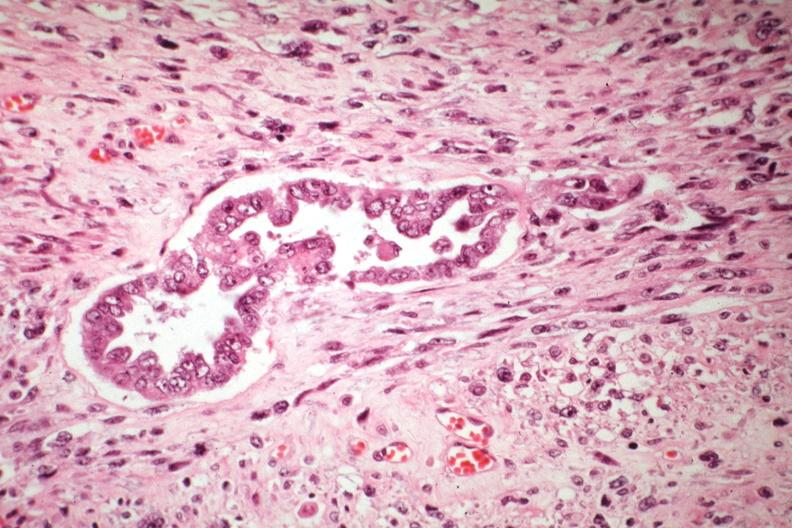does this image show malignant gland and stoma well shown?
Answer the question using a single word or phrase. Yes 